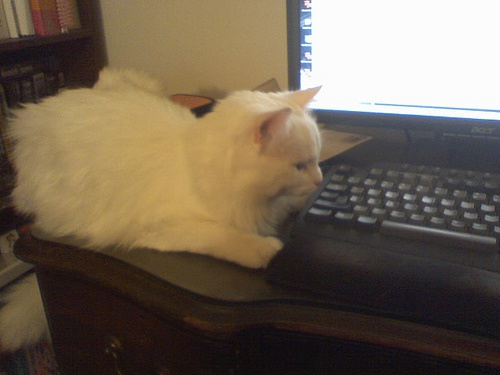Describe the objects in this image and their specific colors. I can see cat in olive, tan, and gray tones, tv in olive, white, gray, and darkgray tones, keyboard in olive, gray, and black tones, book in gray and maroon tones, and book in olive, black, and brown tones in this image. 